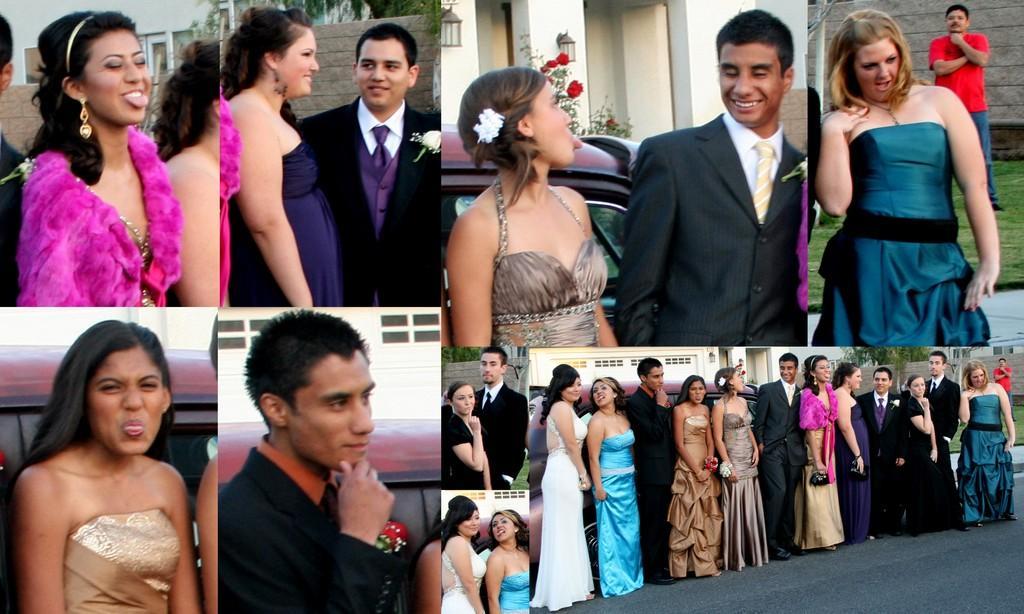Could you give a brief overview of what you see in this image? In this image I can see the collage picture in which I can see few women wearing blue, brown, pink, white and black colored dresses are standing and few men wearing shirts, ties and blazers are standing. In the background I can see a person wearing t shirt and jeans is standing, a vehicle, a building which is cream in color , few trees which are green in color and few flowers which are red in color. 